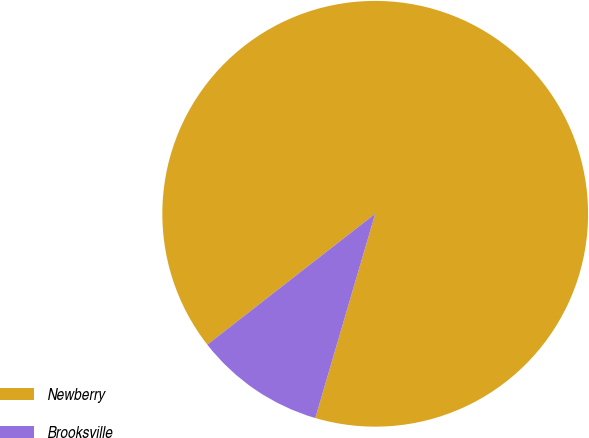<chart> <loc_0><loc_0><loc_500><loc_500><pie_chart><fcel>Newberry<fcel>Brooksville<nl><fcel>90.08%<fcel>9.92%<nl></chart> 